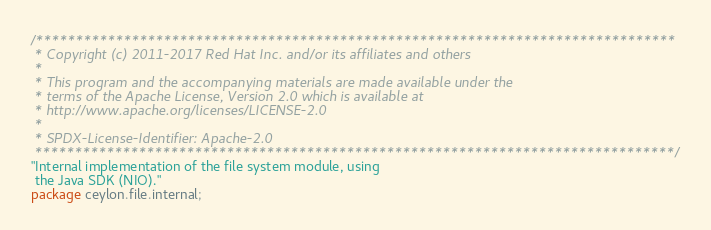<code> <loc_0><loc_0><loc_500><loc_500><_Ceylon_>/********************************************************************************
 * Copyright (c) 2011-2017 Red Hat Inc. and/or its affiliates and others
 *
 * This program and the accompanying materials are made available under the 
 * terms of the Apache License, Version 2.0 which is available at
 * http://www.apache.org/licenses/LICENSE-2.0
 *
 * SPDX-License-Identifier: Apache-2.0 
 ********************************************************************************/
"Internal implementation of the file system module, using 
 the Java SDK (NIO)."
package ceylon.file.internal;
</code> 